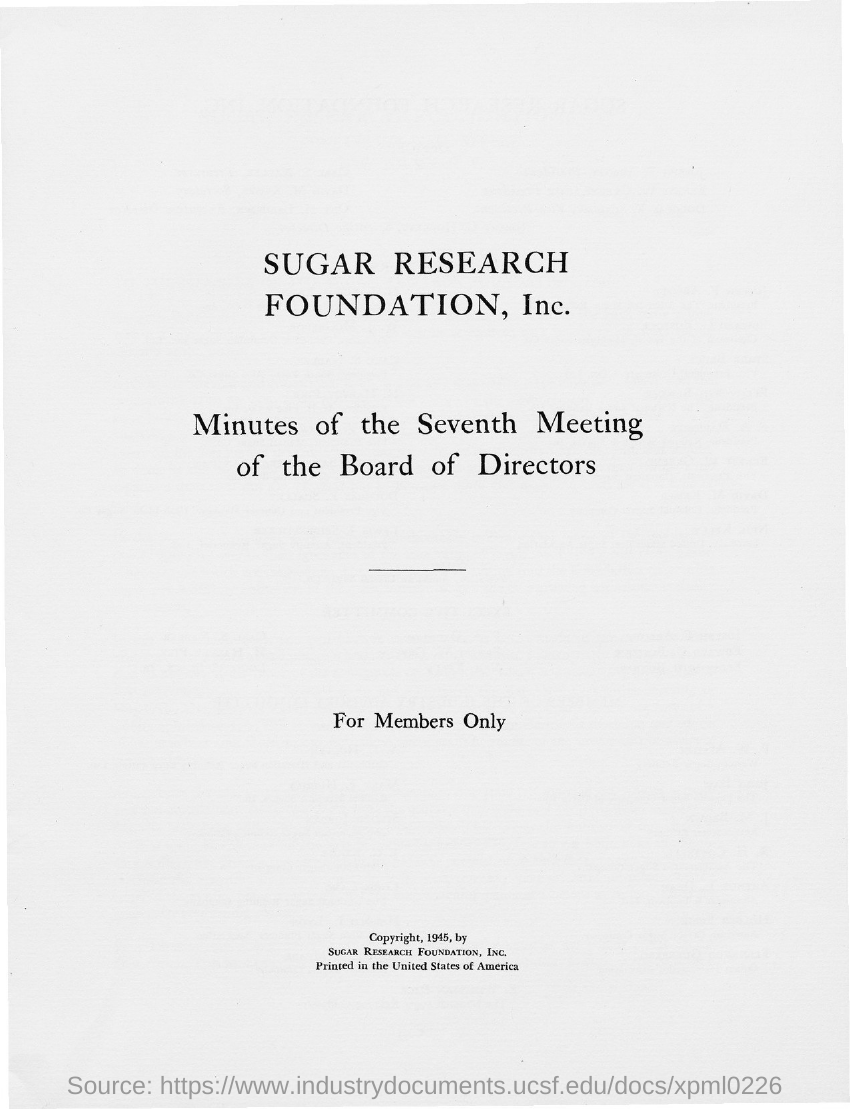Specify some key components in this picture. The copyright holder is Sugar Research Foundation, Inc. 